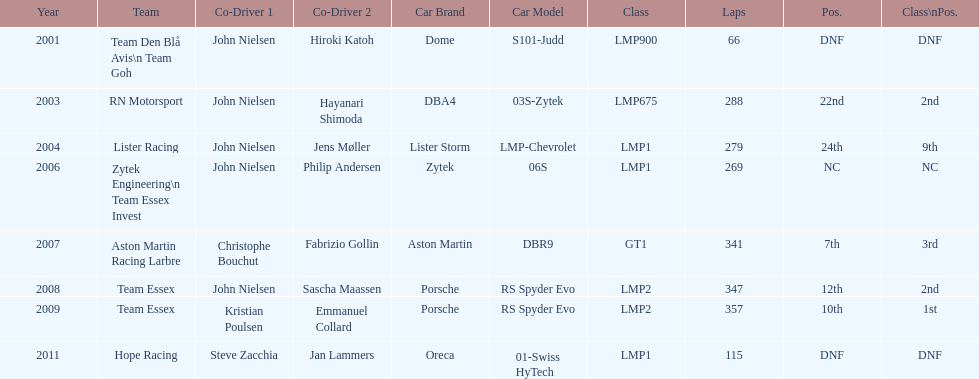Who was casper elgaard's co-driver the most often for the 24 hours of le mans? John Nielsen. 